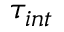<formula> <loc_0><loc_0><loc_500><loc_500>\tau _ { i n t }</formula> 